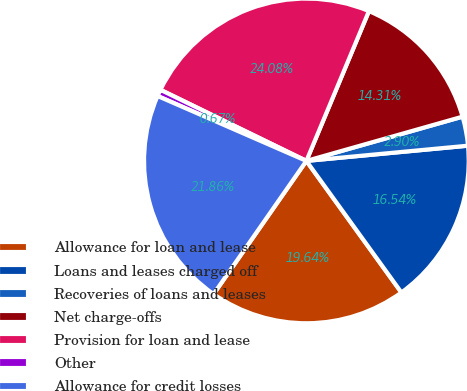Convert chart to OTSL. <chart><loc_0><loc_0><loc_500><loc_500><pie_chart><fcel>Allowance for loan and lease<fcel>Loans and leases charged off<fcel>Recoveries of loans and leases<fcel>Net charge-offs<fcel>Provision for loan and lease<fcel>Other<fcel>Allowance for credit losses<nl><fcel>19.64%<fcel>16.54%<fcel>2.9%<fcel>14.31%<fcel>24.08%<fcel>0.67%<fcel>21.86%<nl></chart> 